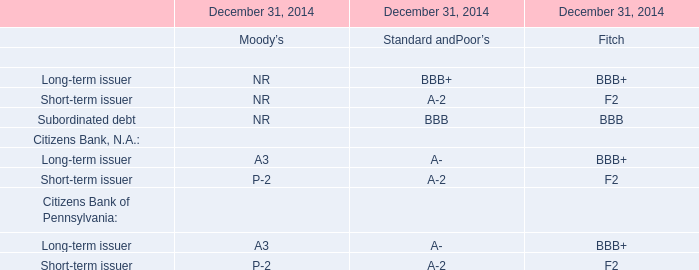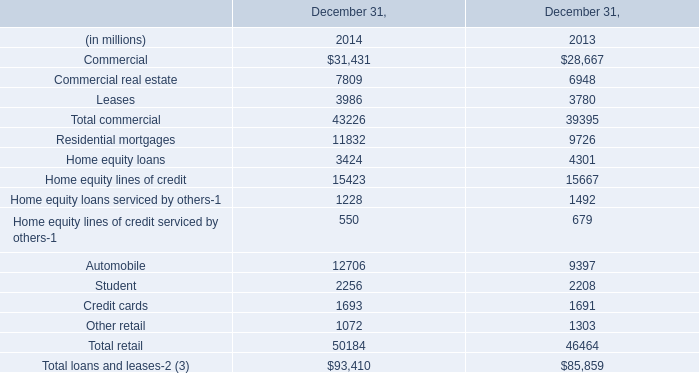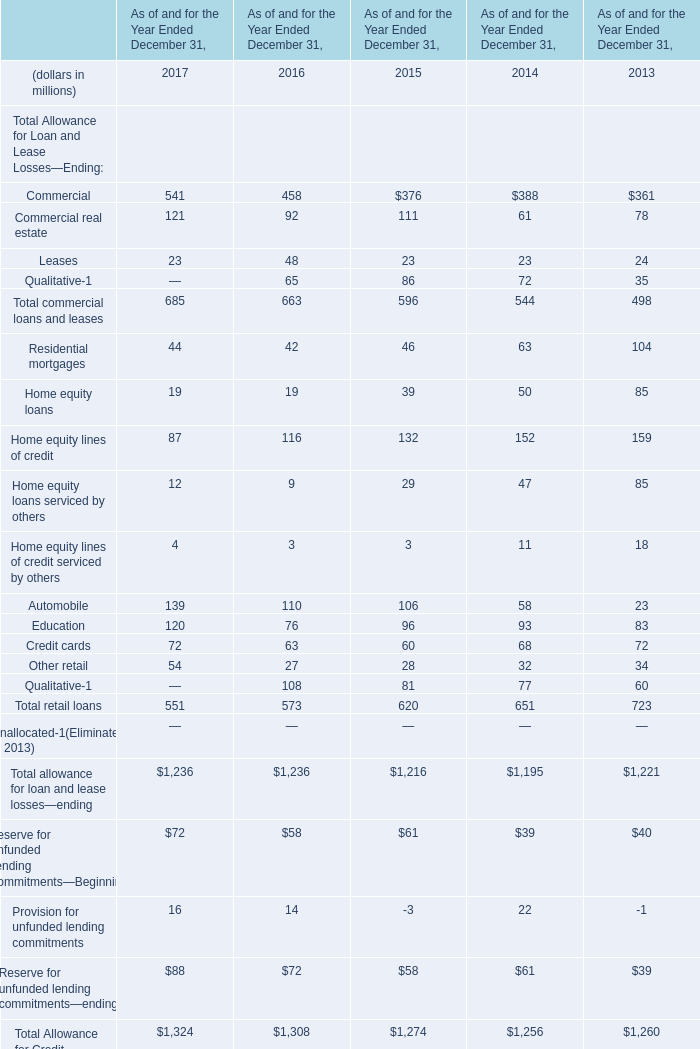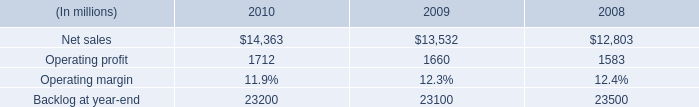In which section the sum of retail loans has the highest value? 
Answer: 2013. 